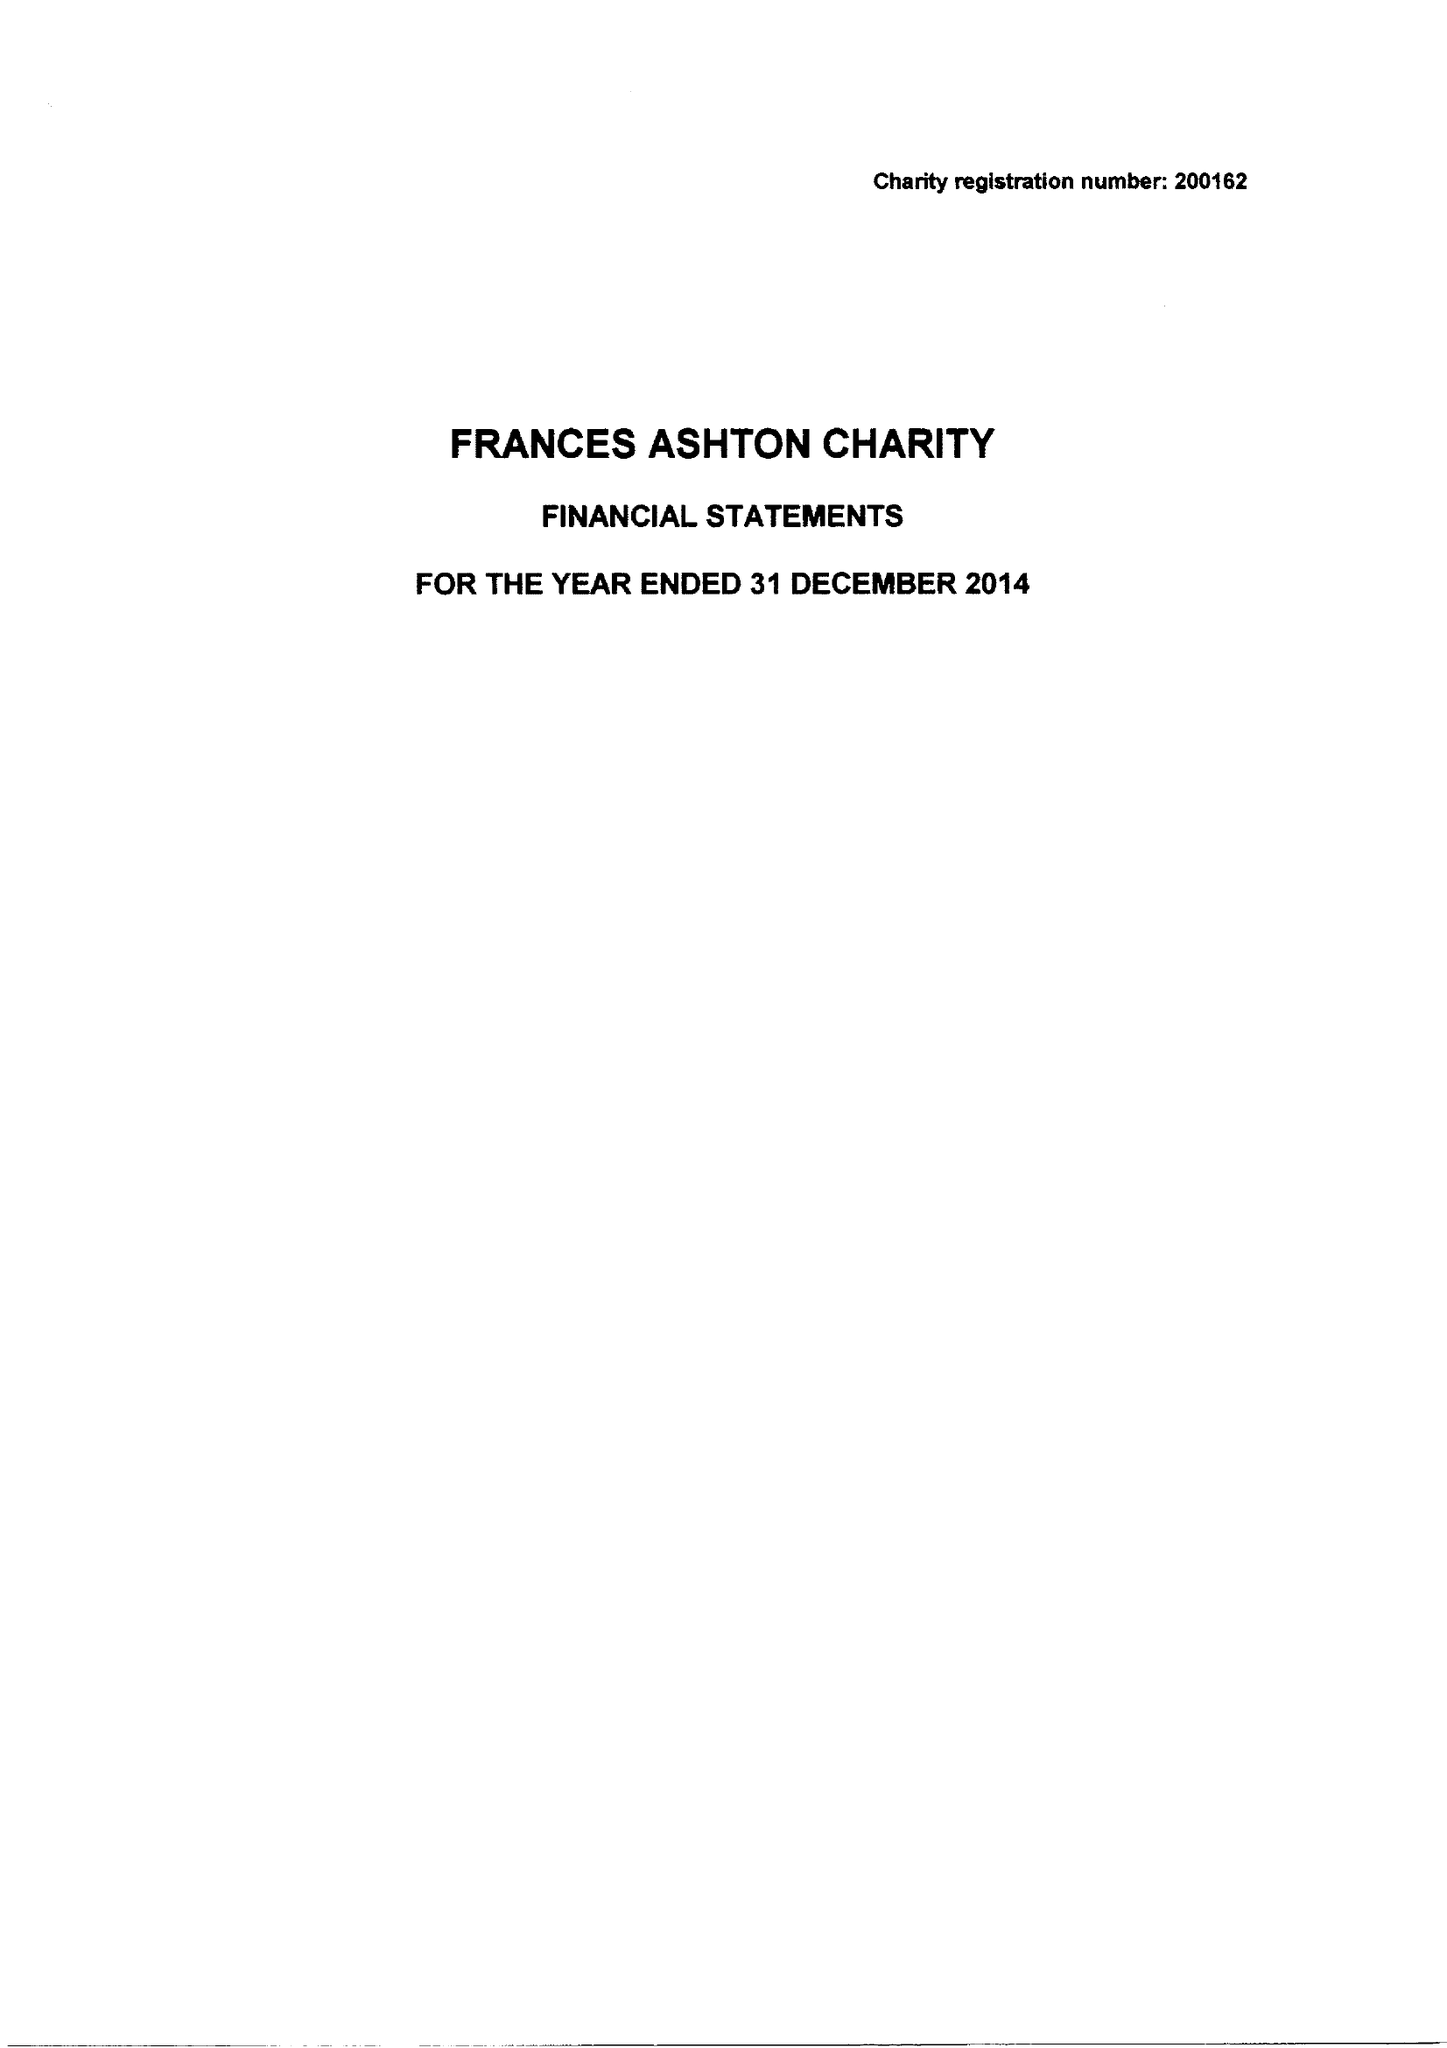What is the value for the address__post_town?
Answer the question using a single word or phrase. ALTON 